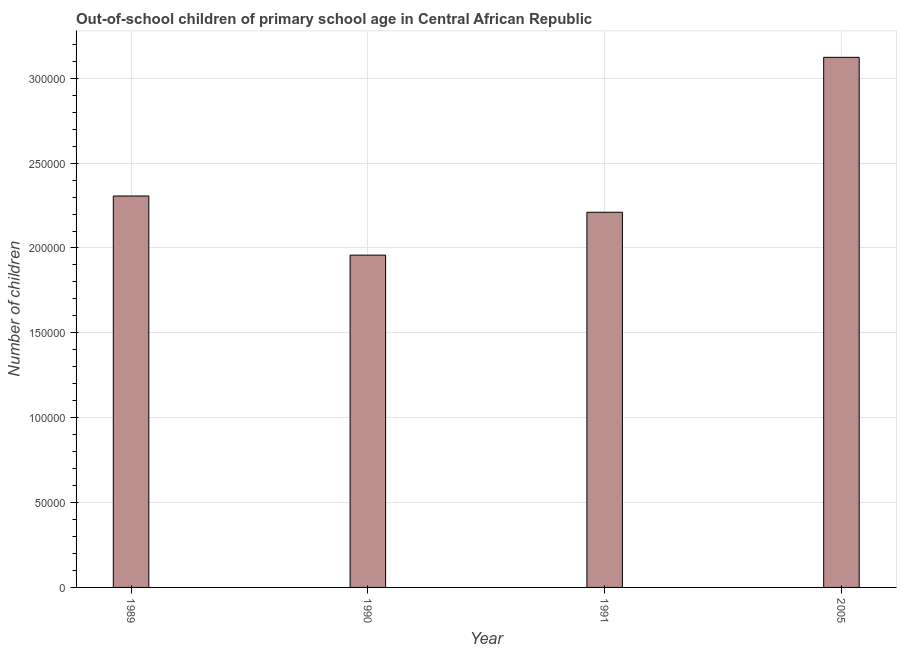Does the graph contain grids?
Make the answer very short. Yes. What is the title of the graph?
Keep it short and to the point. Out-of-school children of primary school age in Central African Republic. What is the label or title of the Y-axis?
Give a very brief answer. Number of children. What is the number of out-of-school children in 1989?
Provide a succinct answer. 2.31e+05. Across all years, what is the maximum number of out-of-school children?
Your answer should be compact. 3.12e+05. Across all years, what is the minimum number of out-of-school children?
Offer a very short reply. 1.96e+05. What is the sum of the number of out-of-school children?
Provide a short and direct response. 9.60e+05. What is the difference between the number of out-of-school children in 1991 and 2005?
Provide a succinct answer. -9.13e+04. What is the average number of out-of-school children per year?
Your response must be concise. 2.40e+05. What is the median number of out-of-school children?
Provide a succinct answer. 2.26e+05. What is the ratio of the number of out-of-school children in 1991 to that in 2005?
Ensure brevity in your answer.  0.71. Is the number of out-of-school children in 1989 less than that in 1991?
Offer a terse response. No. What is the difference between the highest and the second highest number of out-of-school children?
Your answer should be very brief. 8.17e+04. Is the sum of the number of out-of-school children in 1989 and 1990 greater than the maximum number of out-of-school children across all years?
Provide a succinct answer. Yes. What is the difference between the highest and the lowest number of out-of-school children?
Offer a terse response. 1.17e+05. In how many years, is the number of out-of-school children greater than the average number of out-of-school children taken over all years?
Offer a very short reply. 1. How many bars are there?
Offer a terse response. 4. Are the values on the major ticks of Y-axis written in scientific E-notation?
Make the answer very short. No. What is the Number of children in 1989?
Keep it short and to the point. 2.31e+05. What is the Number of children in 1990?
Your response must be concise. 1.96e+05. What is the Number of children of 1991?
Your answer should be very brief. 2.21e+05. What is the Number of children in 2005?
Keep it short and to the point. 3.12e+05. What is the difference between the Number of children in 1989 and 1990?
Make the answer very short. 3.48e+04. What is the difference between the Number of children in 1989 and 1991?
Provide a short and direct response. 9578. What is the difference between the Number of children in 1989 and 2005?
Offer a very short reply. -8.17e+04. What is the difference between the Number of children in 1990 and 1991?
Provide a short and direct response. -2.52e+04. What is the difference between the Number of children in 1990 and 2005?
Keep it short and to the point. -1.17e+05. What is the difference between the Number of children in 1991 and 2005?
Give a very brief answer. -9.13e+04. What is the ratio of the Number of children in 1989 to that in 1990?
Keep it short and to the point. 1.18. What is the ratio of the Number of children in 1989 to that in 1991?
Your answer should be very brief. 1.04. What is the ratio of the Number of children in 1989 to that in 2005?
Provide a short and direct response. 0.74. What is the ratio of the Number of children in 1990 to that in 1991?
Your answer should be compact. 0.89. What is the ratio of the Number of children in 1990 to that in 2005?
Your response must be concise. 0.63. What is the ratio of the Number of children in 1991 to that in 2005?
Provide a succinct answer. 0.71. 